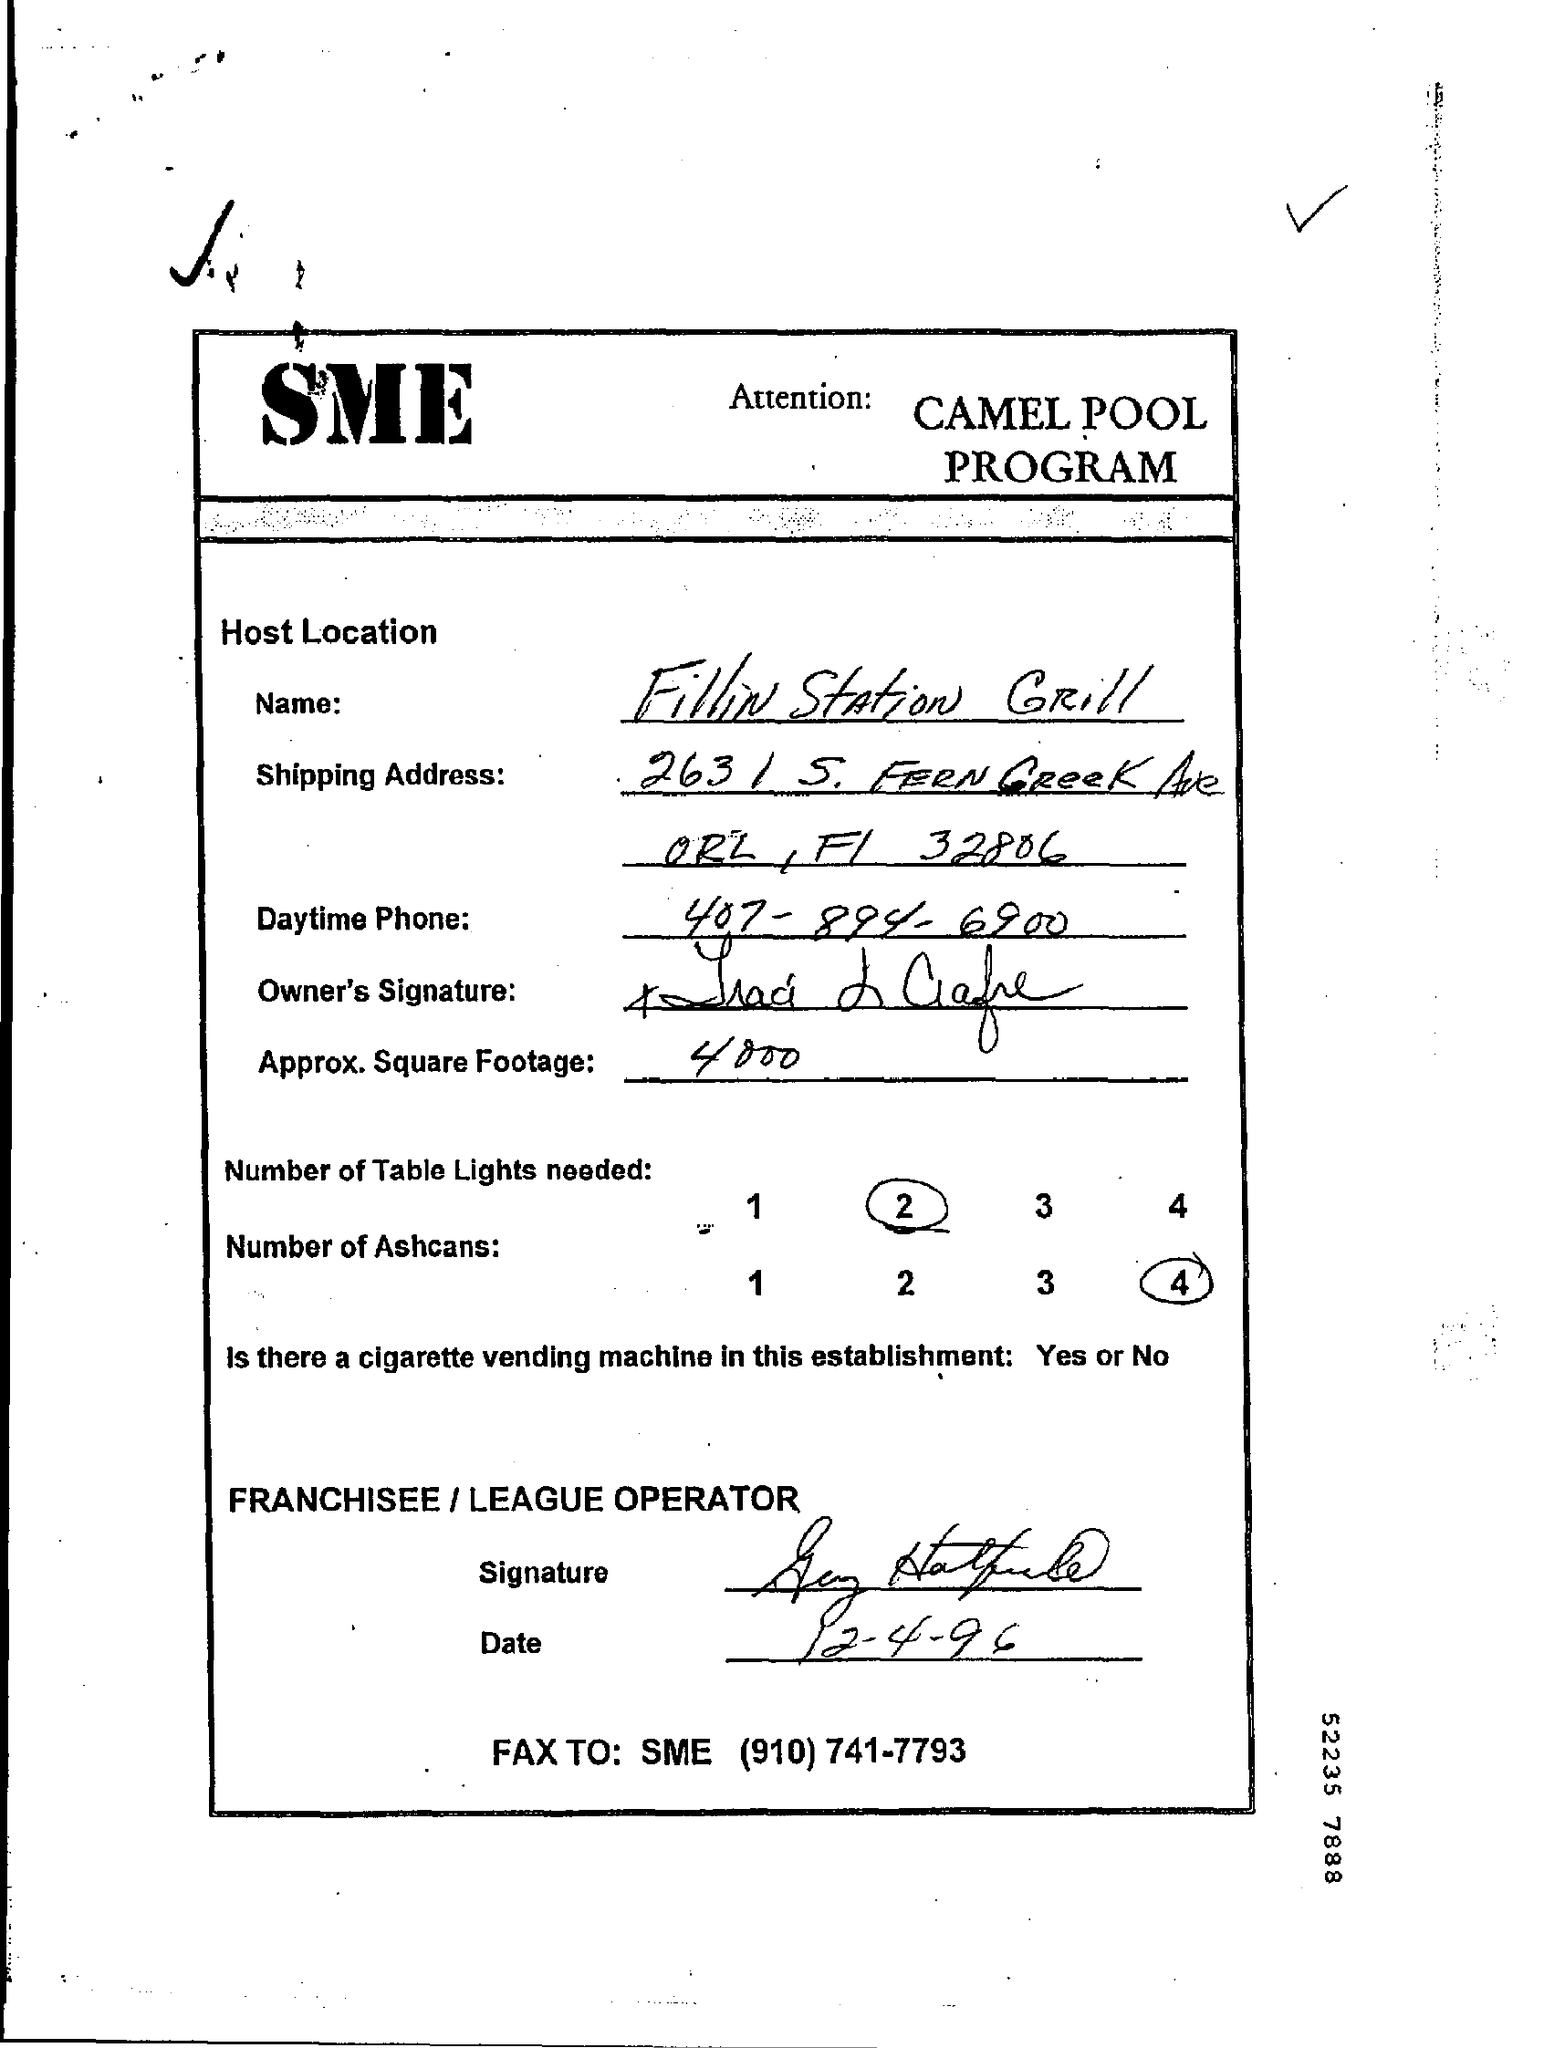Give some essential details in this illustration. What is the date? 12-4-96. The number of ashcans is 4. The FAX TO: is a contact information for a person named SME, who can be reached at (910) 741-7793. The daytime phone number is 407-894-6900. The approximate square footage is approximately 4000 square feet. 